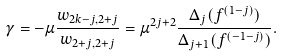<formula> <loc_0><loc_0><loc_500><loc_500>\gamma = - \mu \frac { w _ { 2 k - j , 2 + j } } { w _ { 2 + j , 2 + j } } = \mu ^ { 2 j + 2 } \frac { \Delta _ { j } ( f ^ { ( 1 - j ) } ) } { \Delta _ { j + 1 } ( f ^ { ( - 1 - j ) } ) } .</formula> 